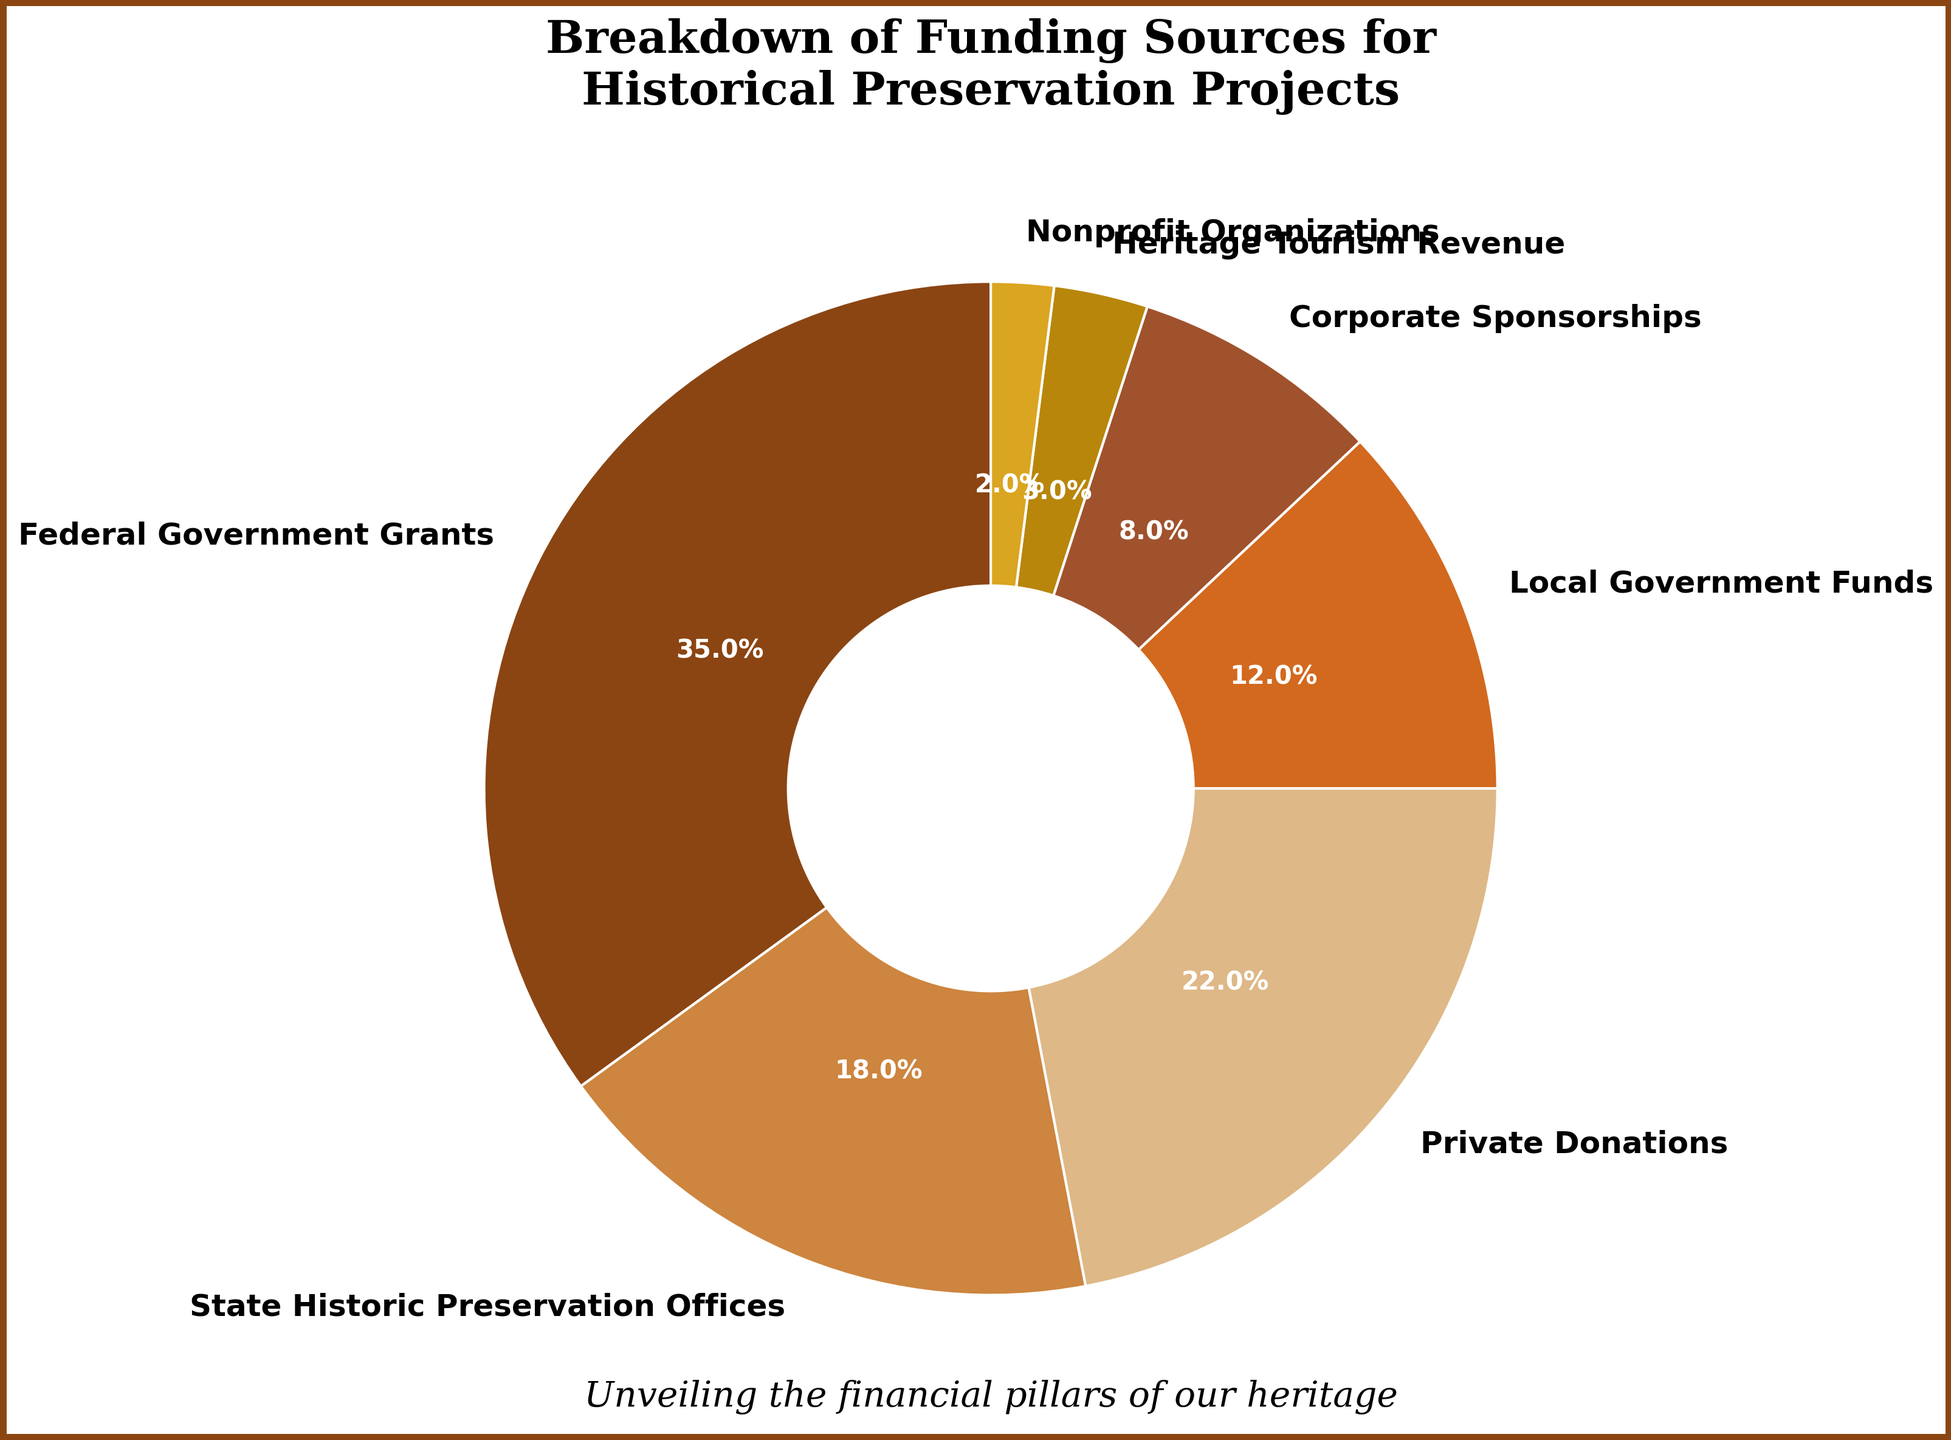what percentage of funding comes from corporate sponsorships? Look at the segment labeled "Corporate Sponsorships" in the pie chart to find its percentage.
Answer: 8% which funding source is the largest contributor? Identify the segment with the biggest portion of the pie chart and check its label.
Answer: Federal Government Grants how much more funding does the federal government provide compared to local government funds? Subtract the percentage of Local Government Funds (12%) from the percentage of Federal Government Grants (35%).
Answer: 23% what is the combined percentage of funding from state historic preservation offices and private donations? Add the percentages of State Historic Preservation Offices (18%) and Private Donations (22%).
Answer: 40% which funding sources collectively contribute less than 10% each? Identify segments contributing less than 10%: Corporate Sponsorships (8%), Heritage Tourism Revenue (3%), and Nonprofit Organizations (2%).
Answer: Corporate Sponsorships, Heritage Tourism Revenue, Nonprofit Organizations what sources together provide the majority of the funding? Combine the percentages from the largest segments until they exceed 50%. Federal Government Grants (35%) + State Historic Preservation Offices (18%) + Private Donations (22%) = 75%.
Answer: Federal Government Grants, State Historic Preservation Offices, Private Donations by what factor is the percentage of private donations greater than that of nonprofit organizations? Divide the percentage of Private Donations (22%) by that of Nonprofit Organizations (2%).
Answer: 11 which source of funding appears to have the smallest contribution visually? Identify the smallest segment of the pie chart and check its label.
Answer: Nonprofit Organizations 